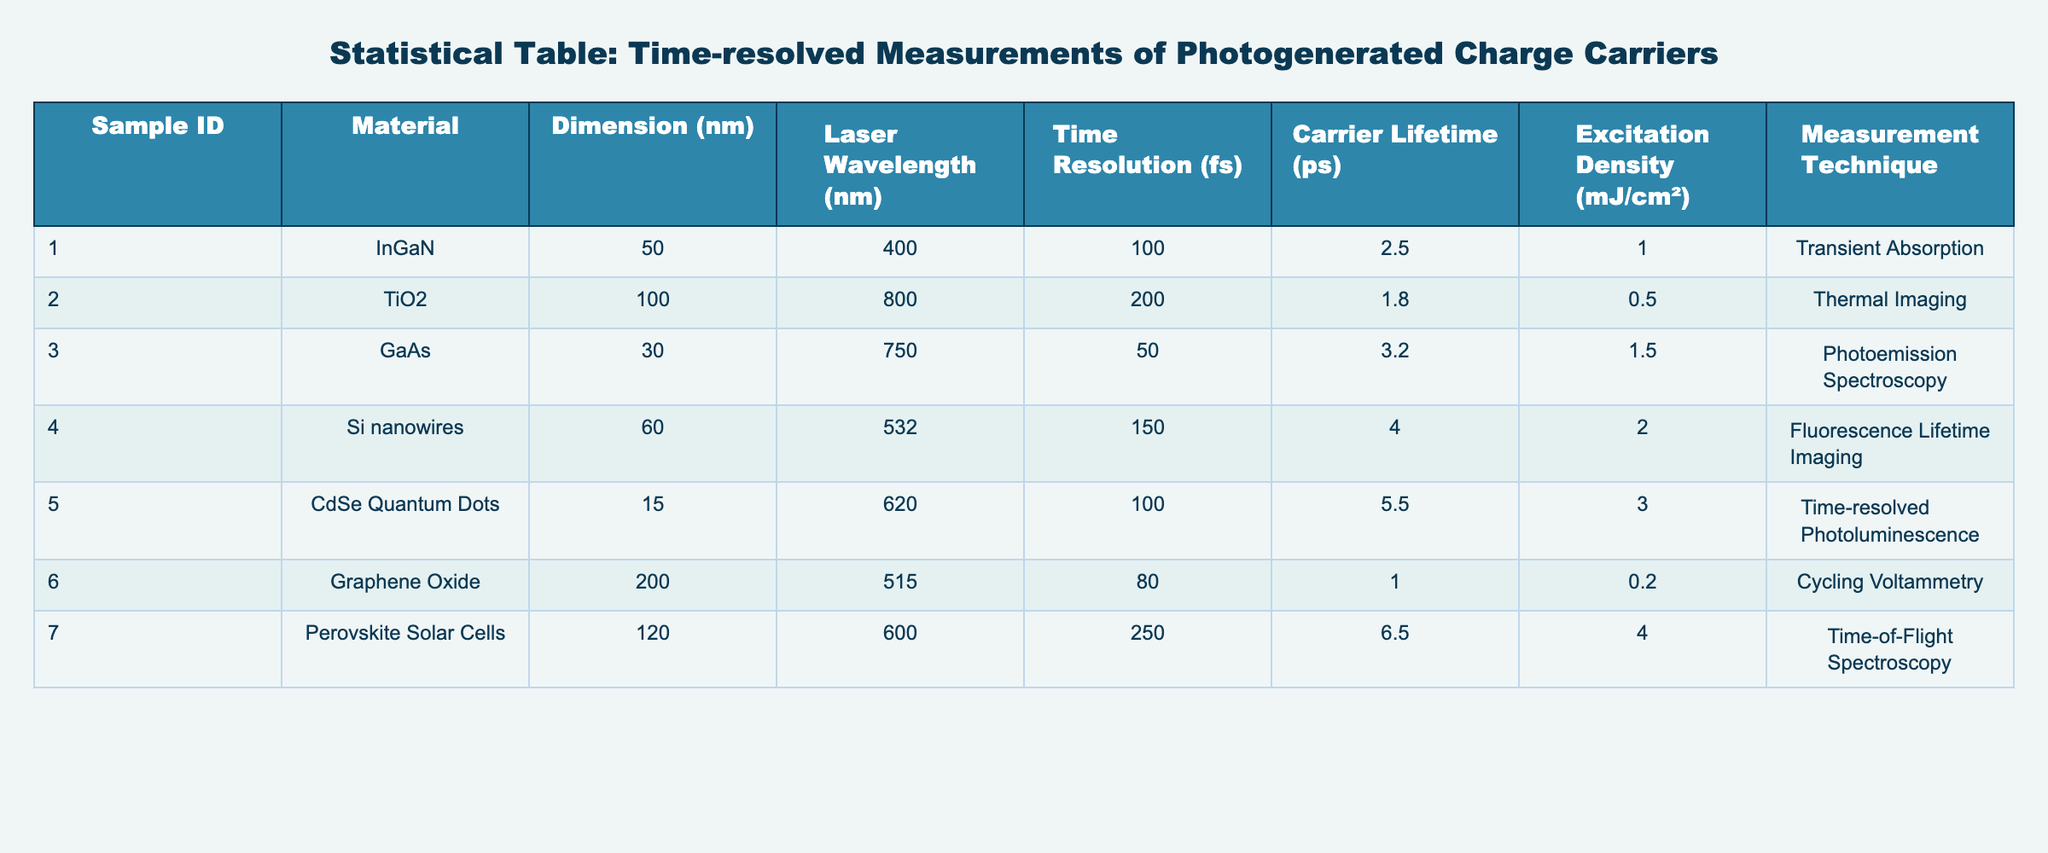What is the carrier lifetime of the CdSe Quantum Dots sample? The carrier lifetime for the CdSe Quantum Dots sample is listed in the corresponding row under the Carrier Lifetime column. In that row, it states "5.5 ps".
Answer: 5.5 ps Which material has the highest carrier lifetime? By examining the Carrier Lifetime column, we can identify the values for each material: 2.5 ps for InGaN, 1.8 ps for TiO2, 3.2 ps for GaAs, 4.0 ps for Si nanowires, 5.5 ps for CdSe Quantum Dots, 1.0 ps for Graphene Oxide, and 6.5 ps for Perovskite Solar Cells. The highest value is "6.5 ps" for Perovskite Solar Cells.
Answer: Perovskite Solar Cells Is the excitation density for TiO2 higher than for GaAs? For TiO2, the excitation density is "0.5 mJ/cm²", and for GaAs, it is "1.5 mJ/cm²". Since 1.5 mJ/cm² is higher than 0.5 mJ/cm², the statement is false.
Answer: No What is the average time resolution of the samples listed? To find the average time resolution, we sum the time resolution values: 100 fs (InGaN) + 200 fs (TiO2) + 50 fs (GaAs) + 150 fs (Si nanowires) + 100 fs (CdSe Quantum Dots) + 80 fs (Graphene Oxide) + 250 fs (Perovskite Solar Cells) = 1030 fs. Then, we divide by the number of samples, which is 7, yielding an average of 1030/7 ≈ 147.14 fs.
Answer: 147.14 fs Which measurement technique has been used for the sample with the smallest dimension? The smallest dimension in the table is 15 nm for the CdSe Quantum Dots. Looking at the corresponding row, we see that the measurement technique used for this sample is "Time-resolved Photoluminescence".
Answer: Time-resolved Photoluminescence Are all samples measured using time-resolved techniques? All the measurement techniques listed in the table— transient absorption, thermal imaging, photoemission spectroscopy, fluorescence lifetime imaging, time-resolved photoluminescence, cycling voltammetry, and time-of-flight spectroscopy—are indeed time-resolved techniques. Thus, the statement is true.
Answer: Yes What is the difference in carrier lifetime between InGaN and Graphene Oxide? The carrier lifetime for InGaN is "2.5 ps", and for Graphene Oxide, it is "1.0 ps". The difference is calculated as 2.5 ps - 1.0 ps = 1.5 ps.
Answer: 1.5 ps 